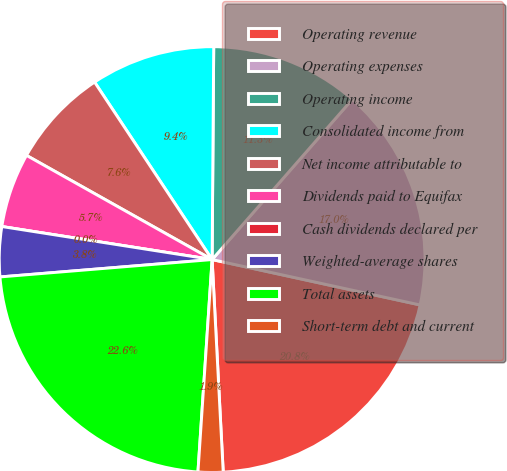<chart> <loc_0><loc_0><loc_500><loc_500><pie_chart><fcel>Operating revenue<fcel>Operating expenses<fcel>Operating income<fcel>Consolidated income from<fcel>Net income attributable to<fcel>Dividends paid to Equifax<fcel>Cash dividends declared per<fcel>Weighted-average shares<fcel>Total assets<fcel>Short-term debt and current<nl><fcel>20.75%<fcel>16.98%<fcel>11.32%<fcel>9.43%<fcel>7.55%<fcel>5.66%<fcel>0.0%<fcel>3.78%<fcel>22.64%<fcel>1.89%<nl></chart> 